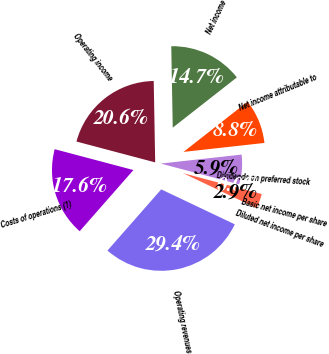<chart> <loc_0><loc_0><loc_500><loc_500><pie_chart><fcel>Operating revenues<fcel>Costs of operations (1)<fcel>Operating income<fcel>Net income<fcel>Net income attributable to<fcel>Dividends on preferred stock<fcel>Basic net income per share<fcel>Diluted net income per share<nl><fcel>29.41%<fcel>17.65%<fcel>20.59%<fcel>14.71%<fcel>8.82%<fcel>5.88%<fcel>0.0%<fcel>2.94%<nl></chart> 